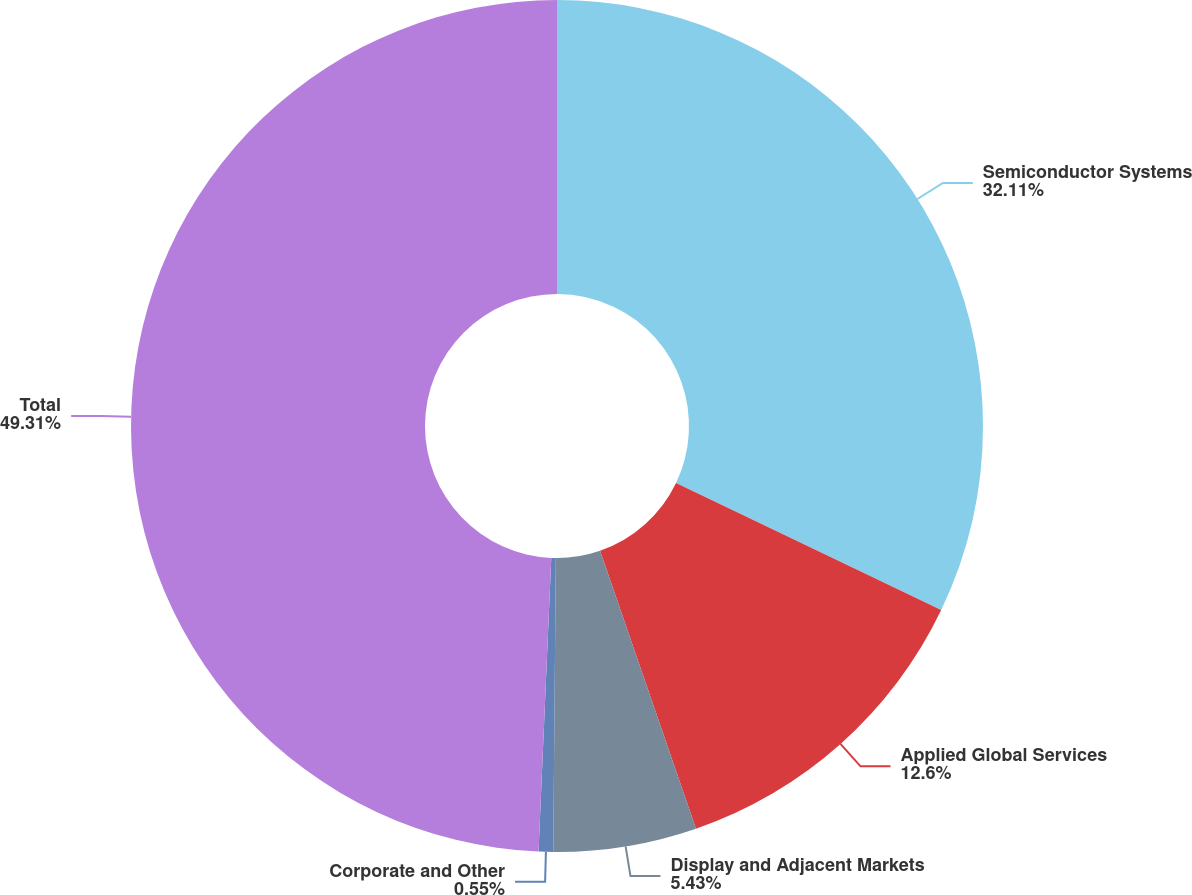Convert chart to OTSL. <chart><loc_0><loc_0><loc_500><loc_500><pie_chart><fcel>Semiconductor Systems<fcel>Applied Global Services<fcel>Display and Adjacent Markets<fcel>Corporate and Other<fcel>Total<nl><fcel>32.11%<fcel>12.6%<fcel>5.43%<fcel>0.55%<fcel>49.31%<nl></chart> 